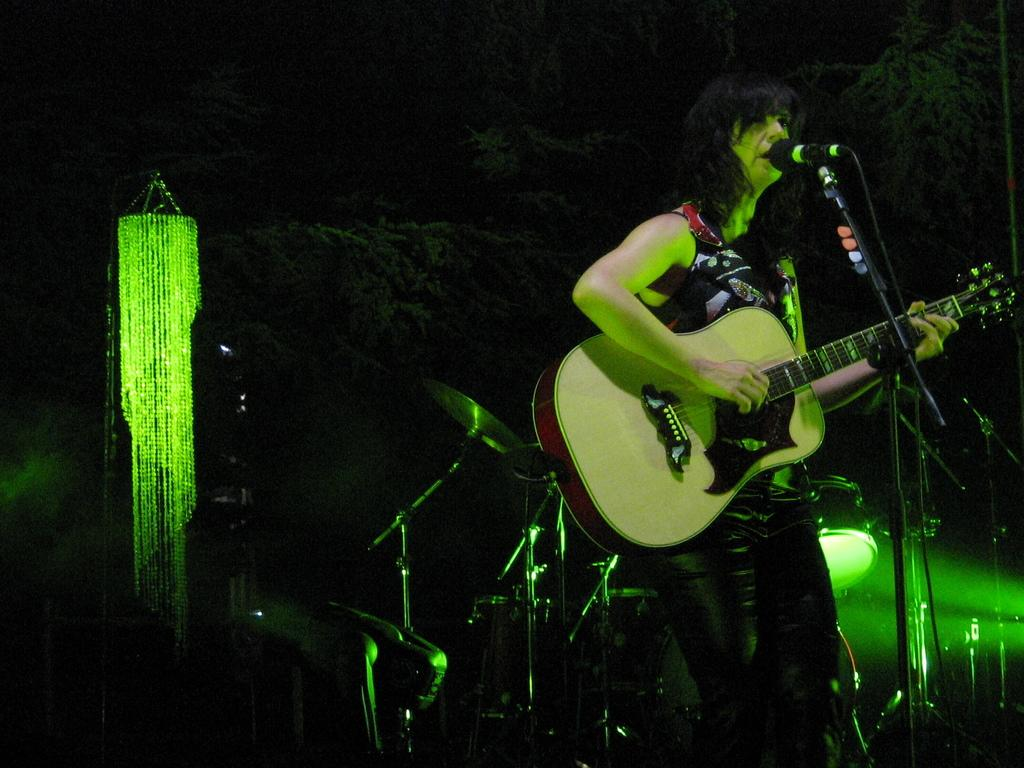Who is the main subject in the image? There is a woman in the image. What is the woman doing in the image? The woman is standing and playing a guitar. How is the guitar being held in the image? The guitar is held in her hand. What object is in front of the woman? There is a microphone in front of her. How does the giraffe help the woman play the guitar in the image? There is no giraffe present in the image, so it cannot help the woman play the guitar. 